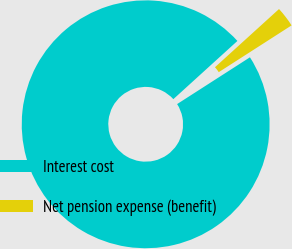Convert chart to OTSL. <chart><loc_0><loc_0><loc_500><loc_500><pie_chart><fcel>Interest cost<fcel>Net pension expense (benefit)<nl><fcel>97.35%<fcel>2.65%<nl></chart> 